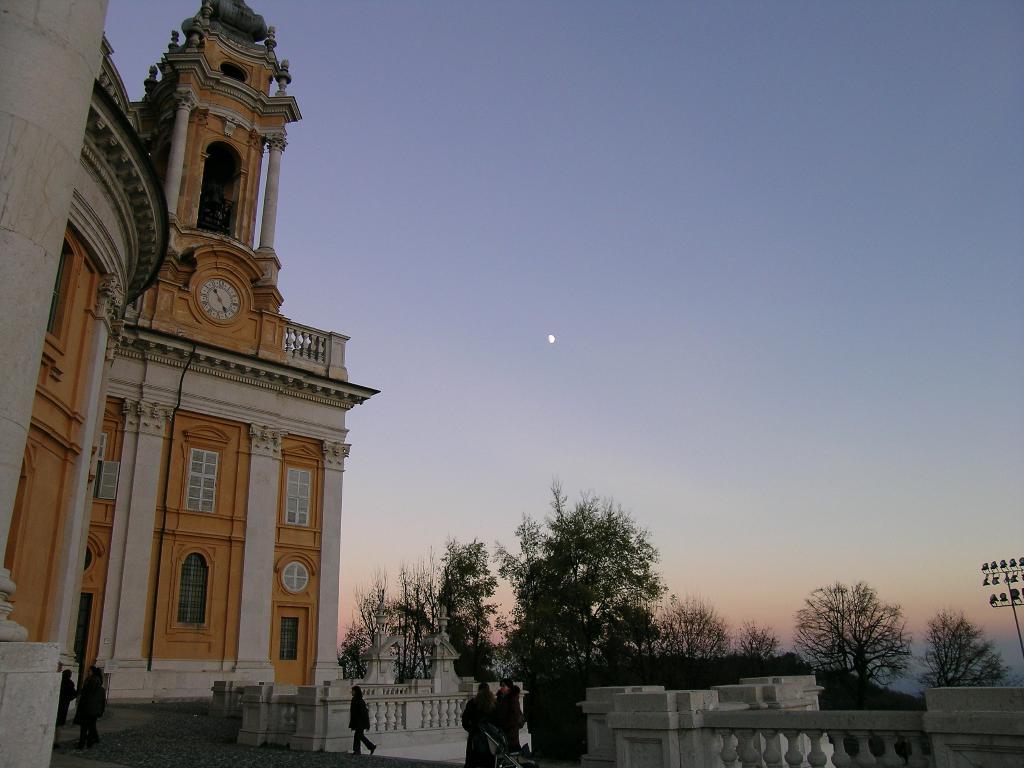Could you give a brief overview of what you see in this image? In this picture we can see a few people and some fencing. There is a building and a clock is visible in it. We can see a few trees and some lights on the right side. 